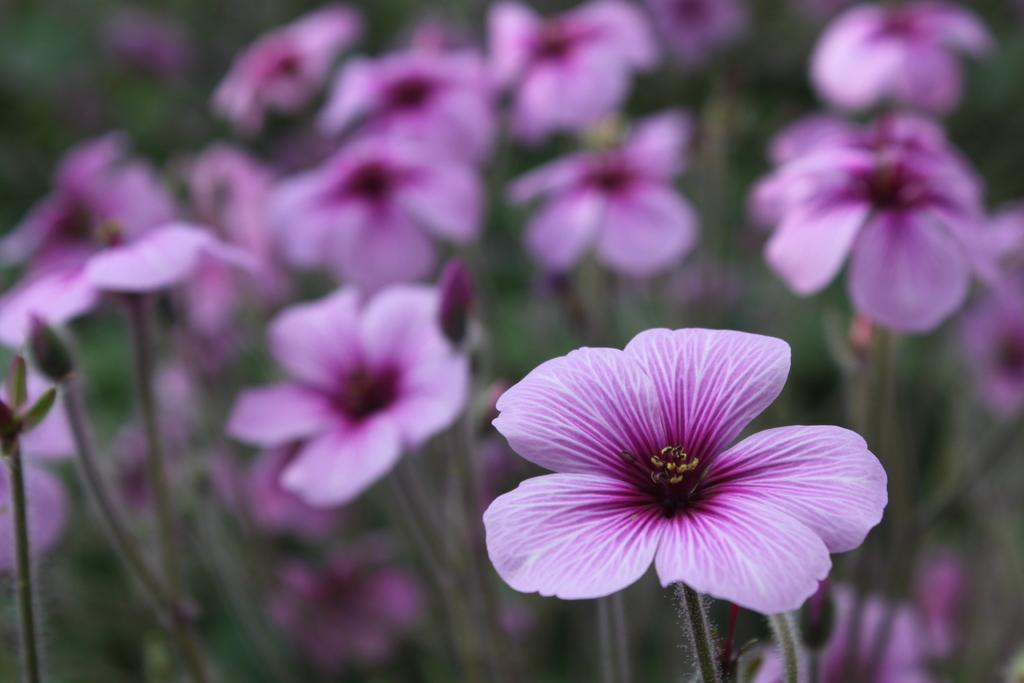What type of living organisms can be seen in the image? There are flowers on plants in the image. Can you describe the plants in the image? The plants in the image have flowers on them. What type of skin condition can be seen on the baby in the image? There is no baby present in the image, only flowers on plants. What sound do the bells make in the image? There are no bells present in the image, only flowers on plants. 